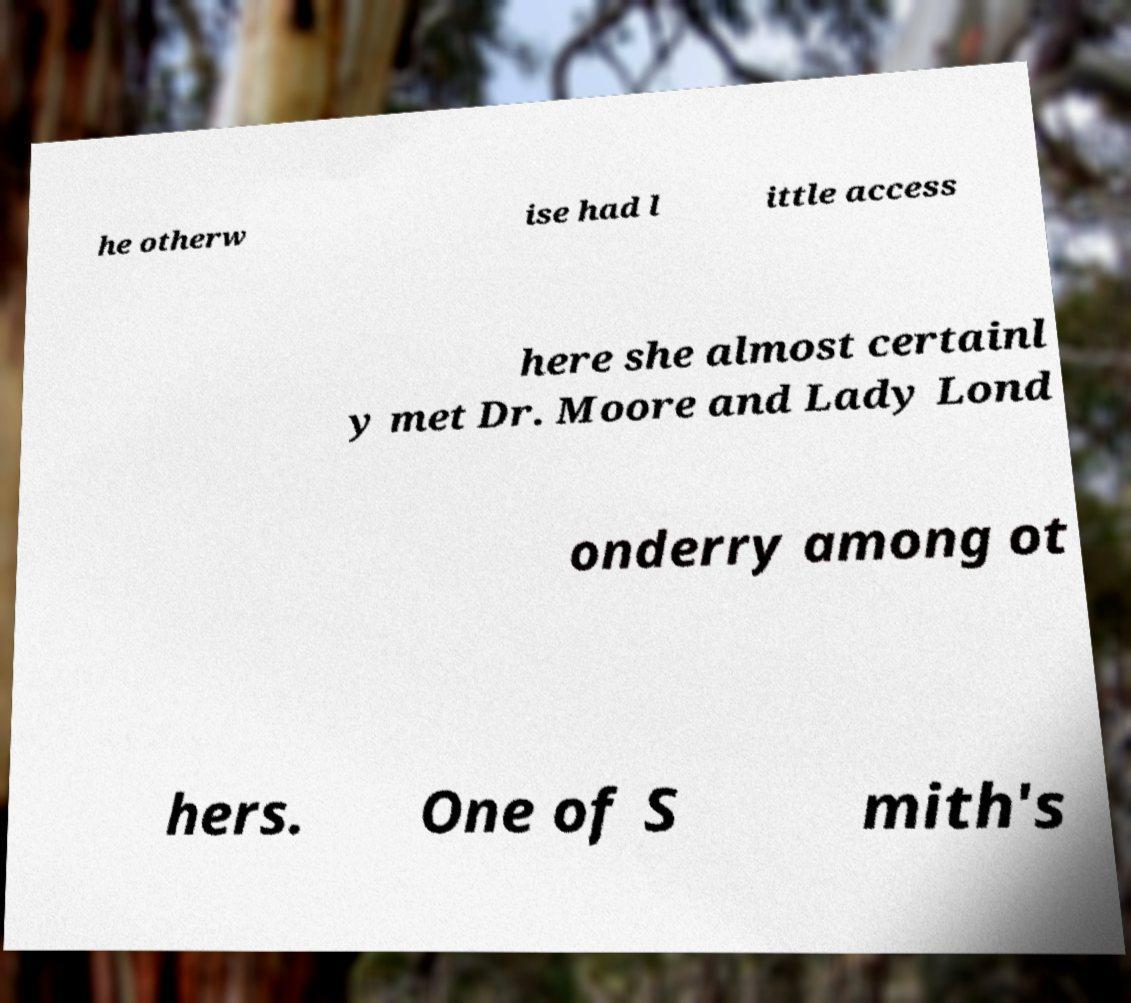Can you accurately transcribe the text from the provided image for me? he otherw ise had l ittle access here she almost certainl y met Dr. Moore and Lady Lond onderry among ot hers. One of S mith's 